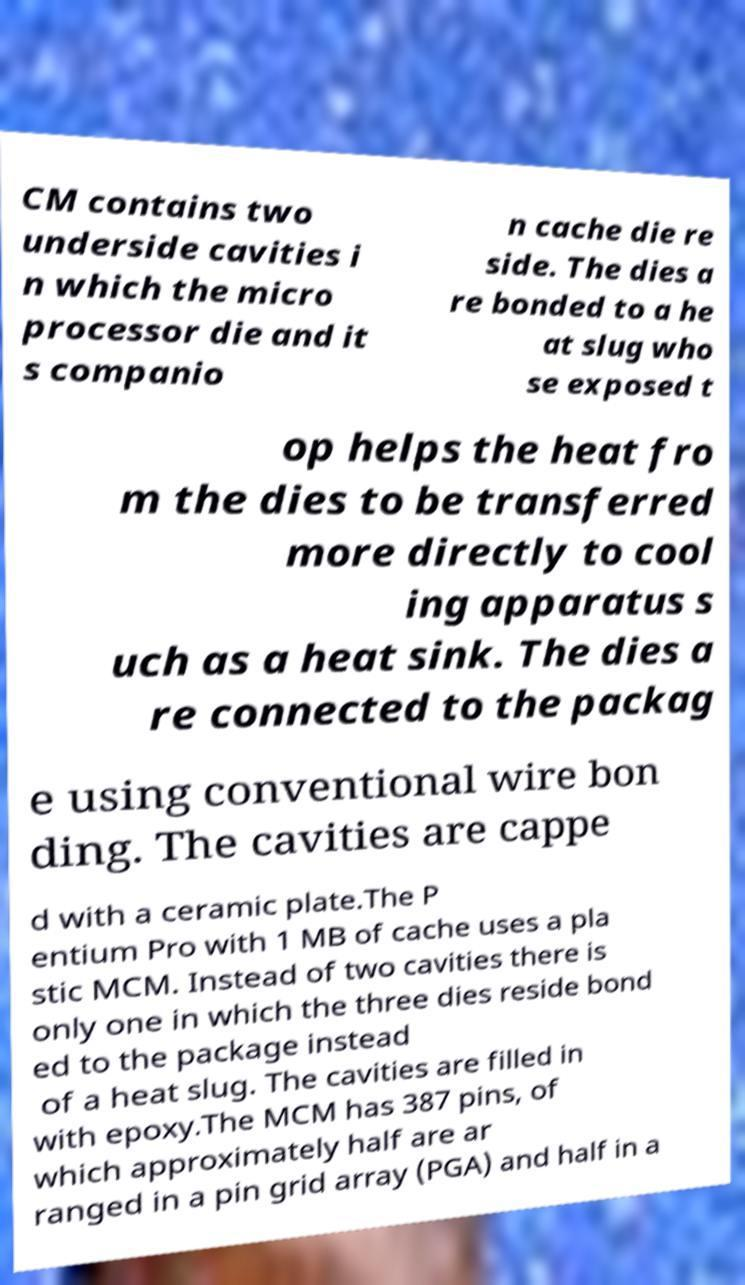Could you extract and type out the text from this image? CM contains two underside cavities i n which the micro processor die and it s companio n cache die re side. The dies a re bonded to a he at slug who se exposed t op helps the heat fro m the dies to be transferred more directly to cool ing apparatus s uch as a heat sink. The dies a re connected to the packag e using conventional wire bon ding. The cavities are cappe d with a ceramic plate.The P entium Pro with 1 MB of cache uses a pla stic MCM. Instead of two cavities there is only one in which the three dies reside bond ed to the package instead of a heat slug. The cavities are filled in with epoxy.The MCM has 387 pins, of which approximately half are ar ranged in a pin grid array (PGA) and half in a 